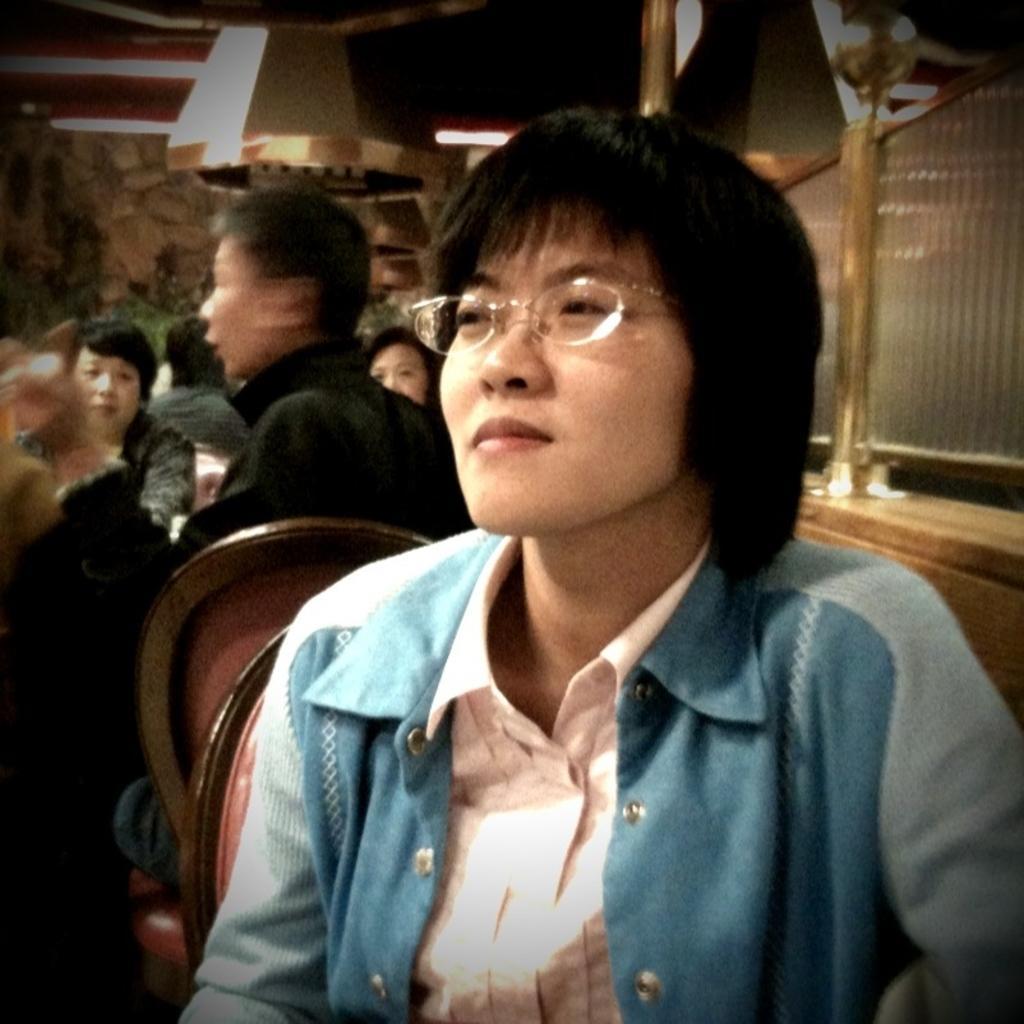In one or two sentences, can you explain what this image depicts? In the image there is a woman in the foreground and behind her there are some other people, on the right side there are two glasses. 